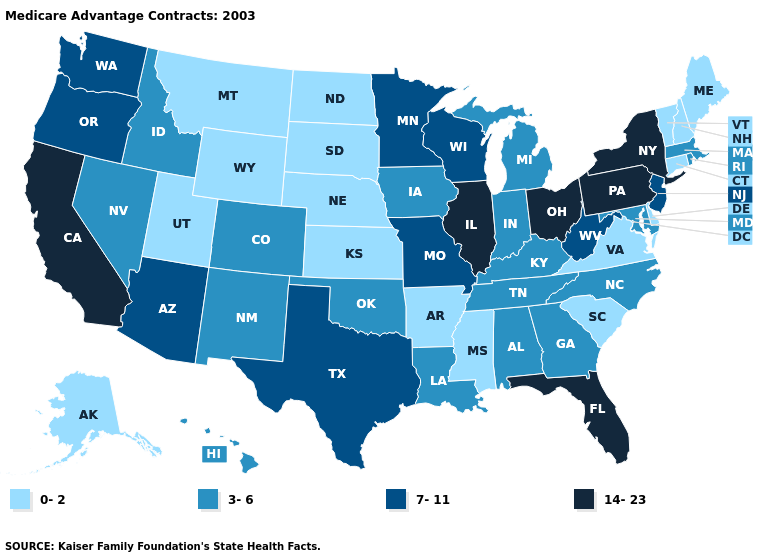What is the value of South Carolina?
Concise answer only. 0-2. Which states hav the highest value in the MidWest?
Quick response, please. Illinois, Ohio. Among the states that border Mississippi , which have the lowest value?
Give a very brief answer. Arkansas. Name the states that have a value in the range 3-6?
Concise answer only. Alabama, Colorado, Georgia, Hawaii, Iowa, Idaho, Indiana, Kentucky, Louisiana, Massachusetts, Maryland, Michigan, North Carolina, New Mexico, Nevada, Oklahoma, Rhode Island, Tennessee. Name the states that have a value in the range 7-11?
Short answer required. Arizona, Minnesota, Missouri, New Jersey, Oregon, Texas, Washington, Wisconsin, West Virginia. What is the value of Hawaii?
Keep it brief. 3-6. What is the value of Michigan?
Answer briefly. 3-6. Does Washington have a lower value than New York?
Keep it brief. Yes. Name the states that have a value in the range 0-2?
Concise answer only. Alaska, Arkansas, Connecticut, Delaware, Kansas, Maine, Mississippi, Montana, North Dakota, Nebraska, New Hampshire, South Carolina, South Dakota, Utah, Virginia, Vermont, Wyoming. Which states have the lowest value in the South?
Be succinct. Arkansas, Delaware, Mississippi, South Carolina, Virginia. What is the value of West Virginia?
Answer briefly. 7-11. Name the states that have a value in the range 7-11?
Give a very brief answer. Arizona, Minnesota, Missouri, New Jersey, Oregon, Texas, Washington, Wisconsin, West Virginia. What is the value of South Dakota?
Give a very brief answer. 0-2. Does the first symbol in the legend represent the smallest category?
Give a very brief answer. Yes. 